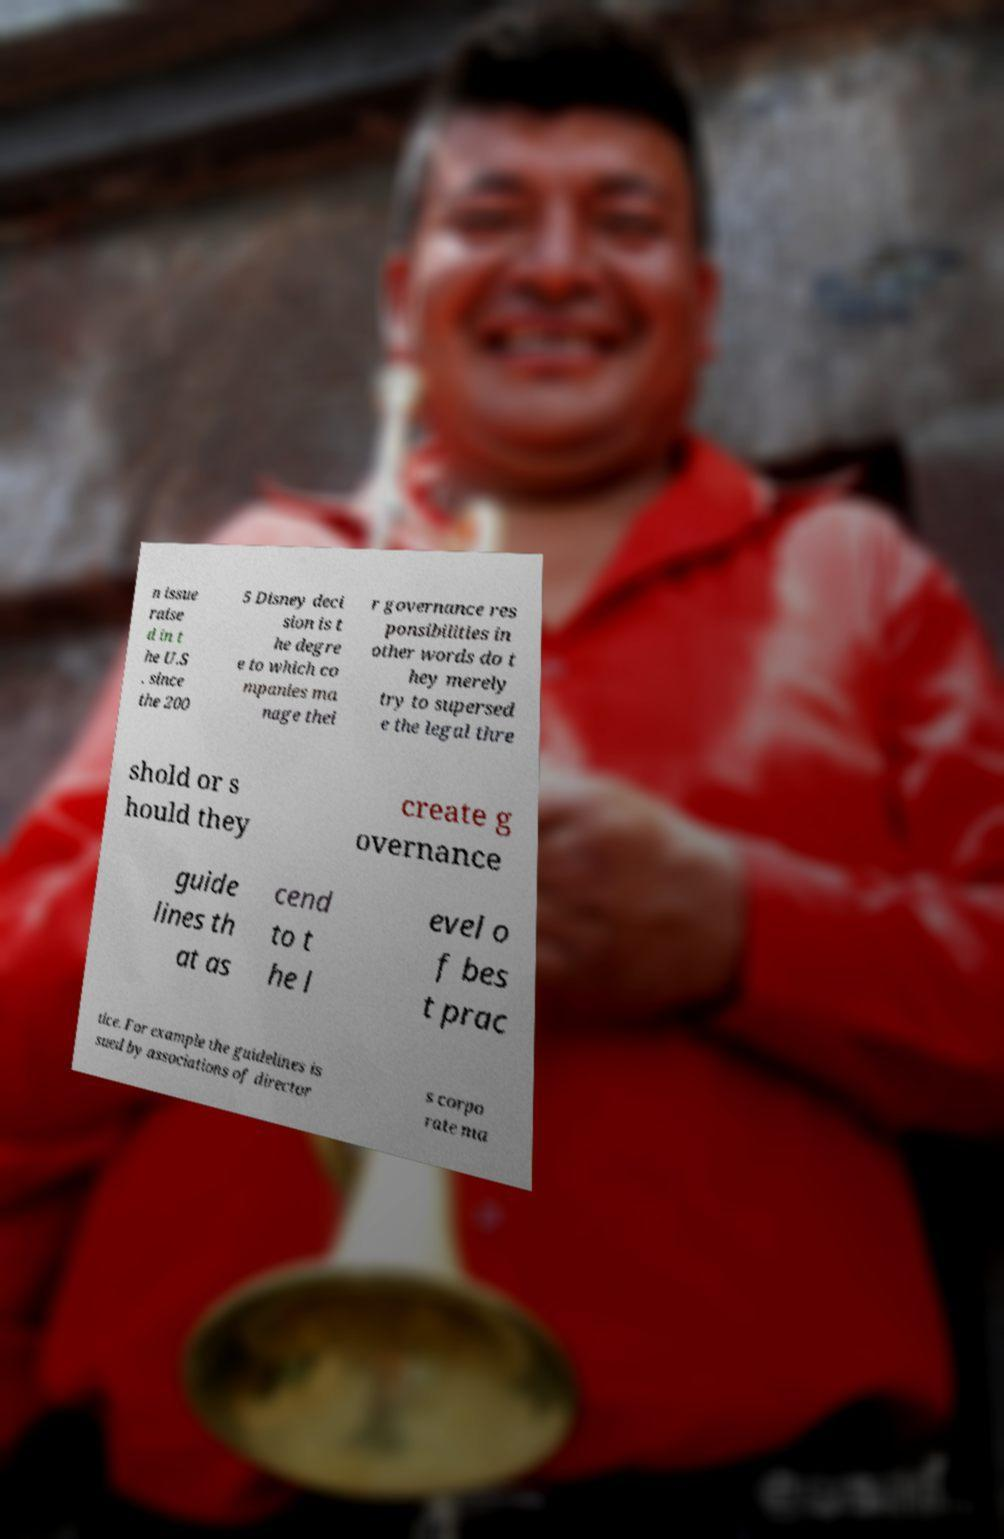For documentation purposes, I need the text within this image transcribed. Could you provide that? n issue raise d in t he U.S . since the 200 5 Disney deci sion is t he degre e to which co mpanies ma nage thei r governance res ponsibilities in other words do t hey merely try to supersed e the legal thre shold or s hould they create g overnance guide lines th at as cend to t he l evel o f bes t prac tice. For example the guidelines is sued by associations of director s corpo rate ma 